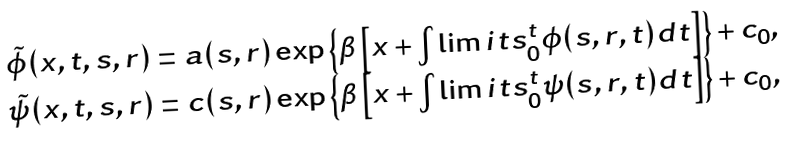Convert formula to latex. <formula><loc_0><loc_0><loc_500><loc_500>\begin{array} { c } \tilde { \phi } ( x , t , s , r ) = a ( s , r ) \exp \left \{ \beta \left [ x + \int \lim i t s _ { 0 } ^ { t } \phi ( s , r , t ) d t \right ] \right \} + c _ { 0 } , \\ \tilde { \psi } ( x , t , s , r ) = c ( s , r ) \exp \left \{ \beta \left [ x + \int \lim i t s _ { 0 } ^ { t } \psi ( s , r , t ) d t \right ] \right \} + c _ { 0 } , \end{array}</formula> 